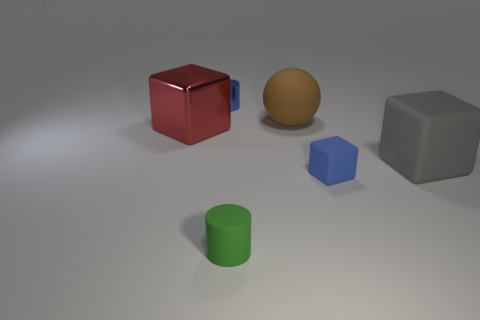Subtract all tiny blocks. How many blocks are left? 2 Add 3 gray metallic blocks. How many objects exist? 9 Subtract all spheres. How many objects are left? 5 Subtract 0 gray cylinders. How many objects are left? 6 Subtract all small blue cylinders. Subtract all metal cylinders. How many objects are left? 4 Add 5 small blue metallic cylinders. How many small blue metallic cylinders are left? 6 Add 4 big matte objects. How many big matte objects exist? 6 